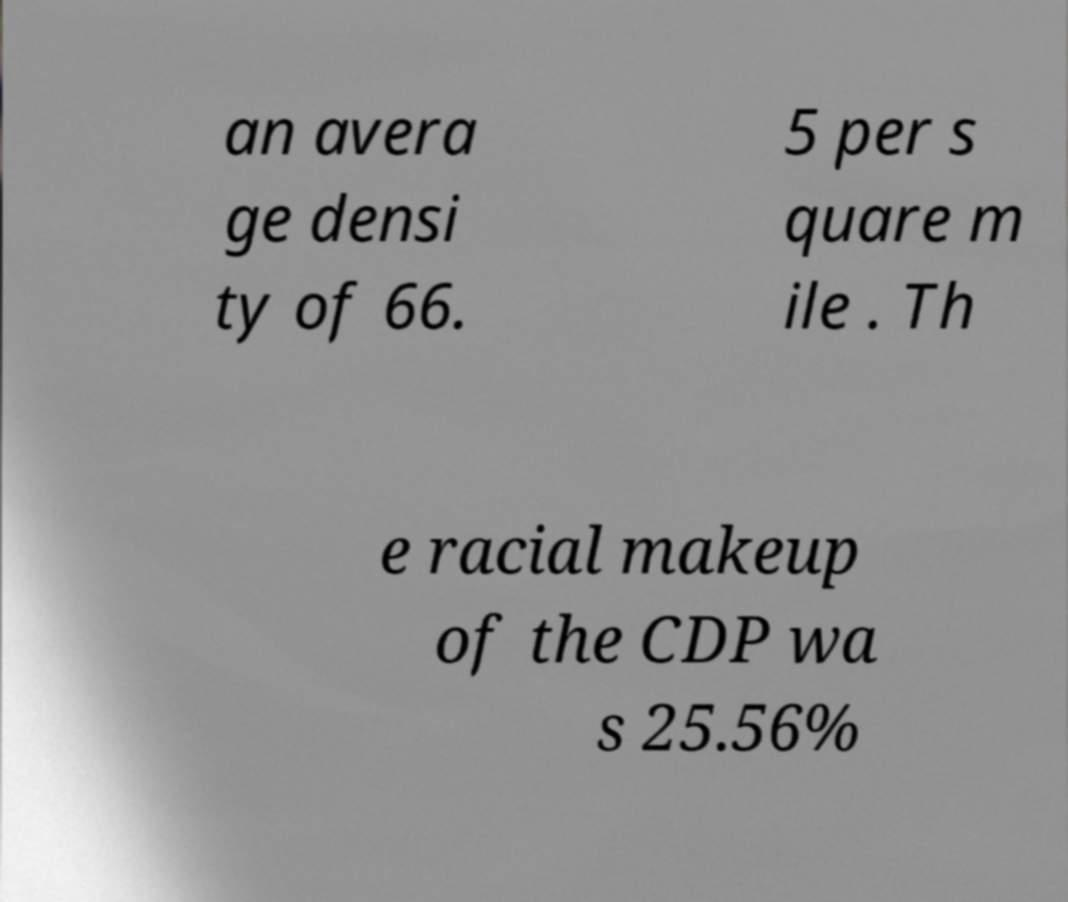What messages or text are displayed in this image? I need them in a readable, typed format. an avera ge densi ty of 66. 5 per s quare m ile . Th e racial makeup of the CDP wa s 25.56% 